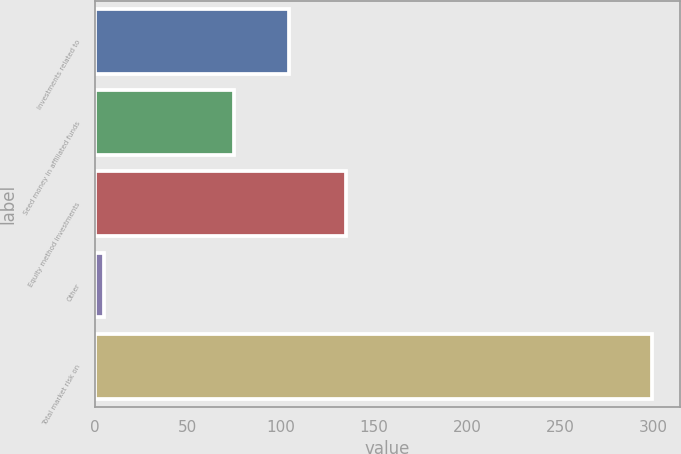Convert chart. <chart><loc_0><loc_0><loc_500><loc_500><bar_chart><fcel>Investments related to<fcel>Seed money in affiliated funds<fcel>Equity method investments<fcel>Other<fcel>Total market risk on<nl><fcel>104.21<fcel>74.8<fcel>134.7<fcel>5.3<fcel>299.4<nl></chart> 